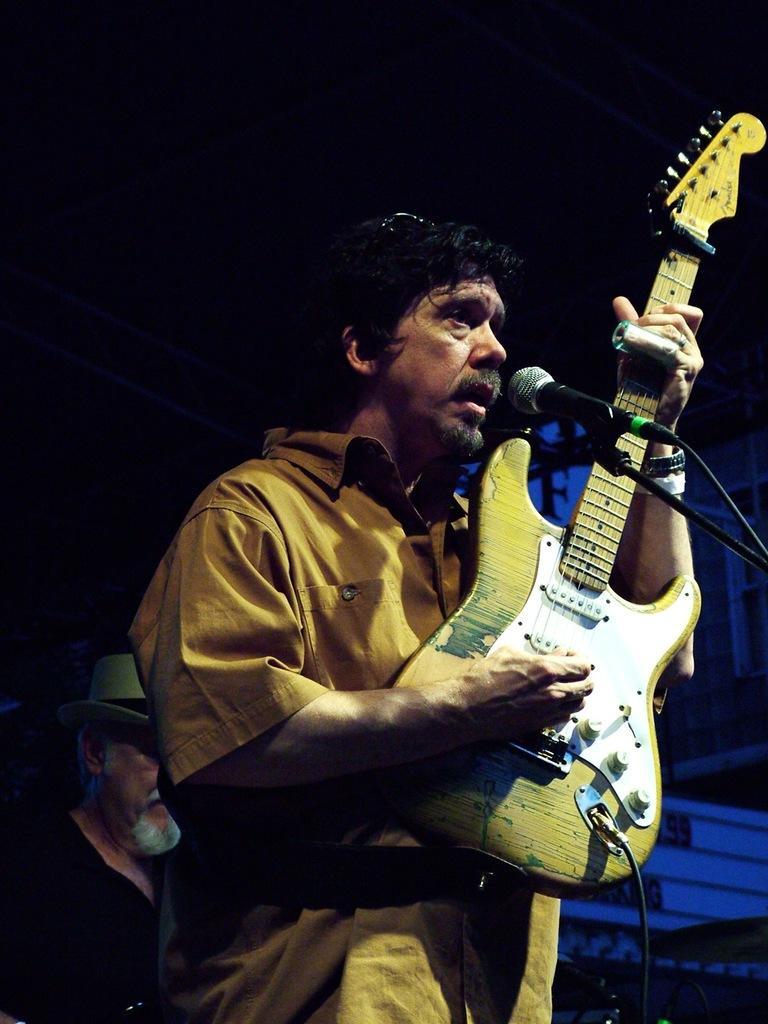In one or two sentences, can you explain what this image depicts? In this picture we can see a man who is playing guitar. And this is mike. 